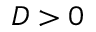Convert formula to latex. <formula><loc_0><loc_0><loc_500><loc_500>D > 0</formula> 